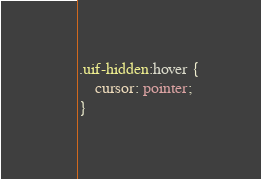<code> <loc_0><loc_0><loc_500><loc_500><_CSS_>.uif-hidden:hover {
	cursor: pointer;
}</code> 